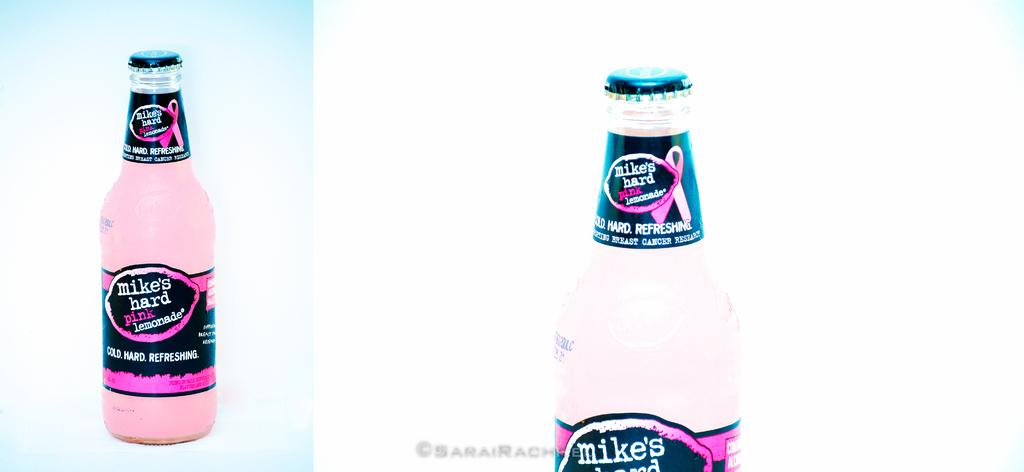<image>
Share a concise interpretation of the image provided. A bottle of Mike's hard pink lemonade with a breast cancer awareness ribbon on the label. 